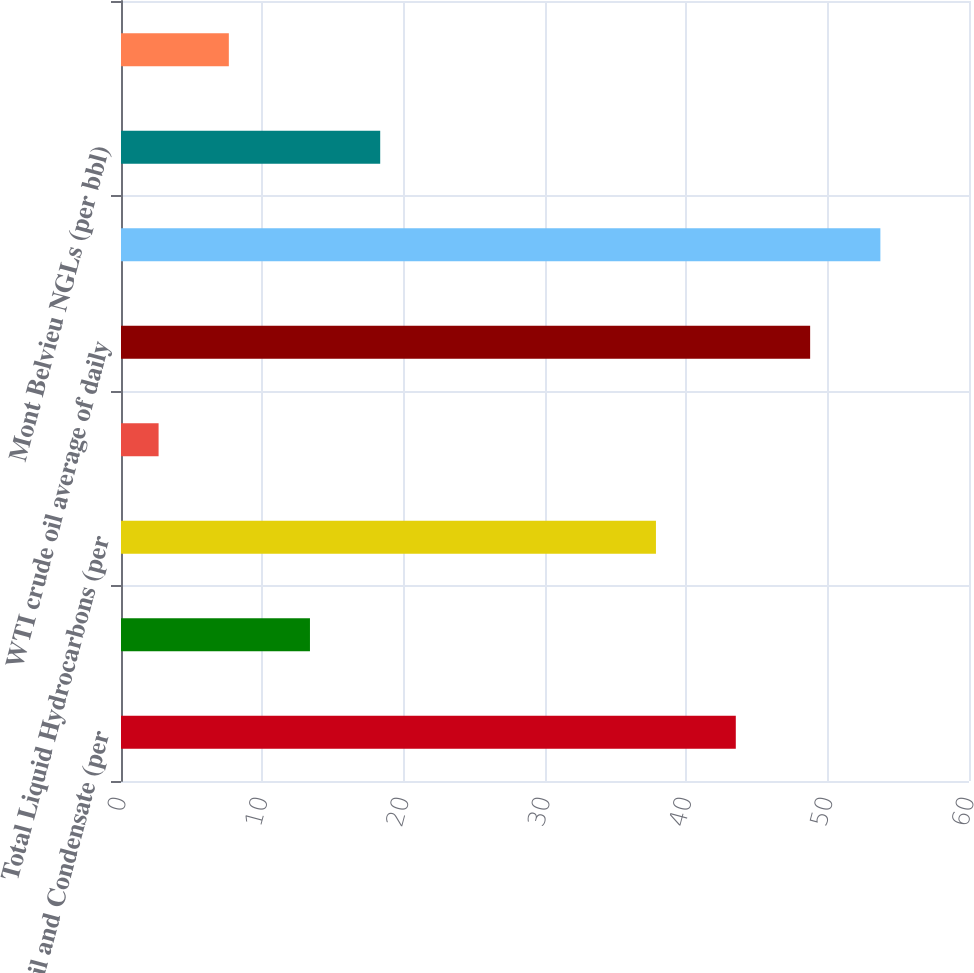Convert chart. <chart><loc_0><loc_0><loc_500><loc_500><bar_chart><fcel>Crude Oil and Condensate (per<fcel>Natural Gas Liquids (per bbl)<fcel>Total Liquid Hydrocarbons (per<fcel>Natural Gas (per mcf)<fcel>WTI crude oil average of daily<fcel>LLS crude oil average of daily<fcel>Mont Belvieu NGLs (per bbl)<fcel>Henry Hub natural gas<nl><fcel>43.5<fcel>13.37<fcel>37.85<fcel>2.66<fcel>48.76<fcel>53.73<fcel>18.34<fcel>7.63<nl></chart> 